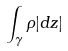Convert formula to latex. <formula><loc_0><loc_0><loc_500><loc_500>\int _ { \gamma } \rho | d z |</formula> 